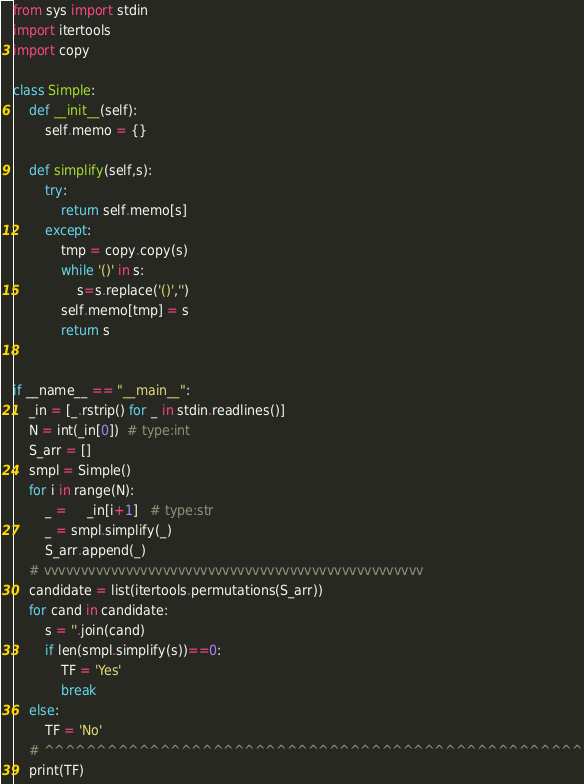<code> <loc_0><loc_0><loc_500><loc_500><_Python_>from sys import stdin
import itertools
import copy

class Simple:
    def __init__(self):
        self.memo = {}
    
    def simplify(self,s):
        try:
            return self.memo[s]
        except:
            tmp = copy.copy(s)
            while '()' in s:
                s=s.replace('()','')
            self.memo[tmp] = s
            return s


if __name__ == "__main__":
    _in = [_.rstrip() for _ in stdin.readlines()]
    N = int(_in[0])  # type:int
    S_arr = []
    smpl = Simple()
    for i in range(N):
        _ =     _in[i+1]   # type:str
        _ = smpl.simplify(_)
        S_arr.append(_)
    # vvvvvvvvvvvvvvvvvvvvvvvvvvvvvvvvvvvvvvvvvvvvvvvvvvv
    candidate = list(itertools.permutations(S_arr))
    for cand in candidate:
        s = ''.join(cand)
        if len(smpl.simplify(s))==0:
            TF = 'Yes'
            break
    else:
        TF = 'No'
    # ^^^^^^^^^^^^^^^^^^^^^^^^^^^^^^^^^^^^^^^^^^^^^^^^^^^
    print(TF)
</code> 